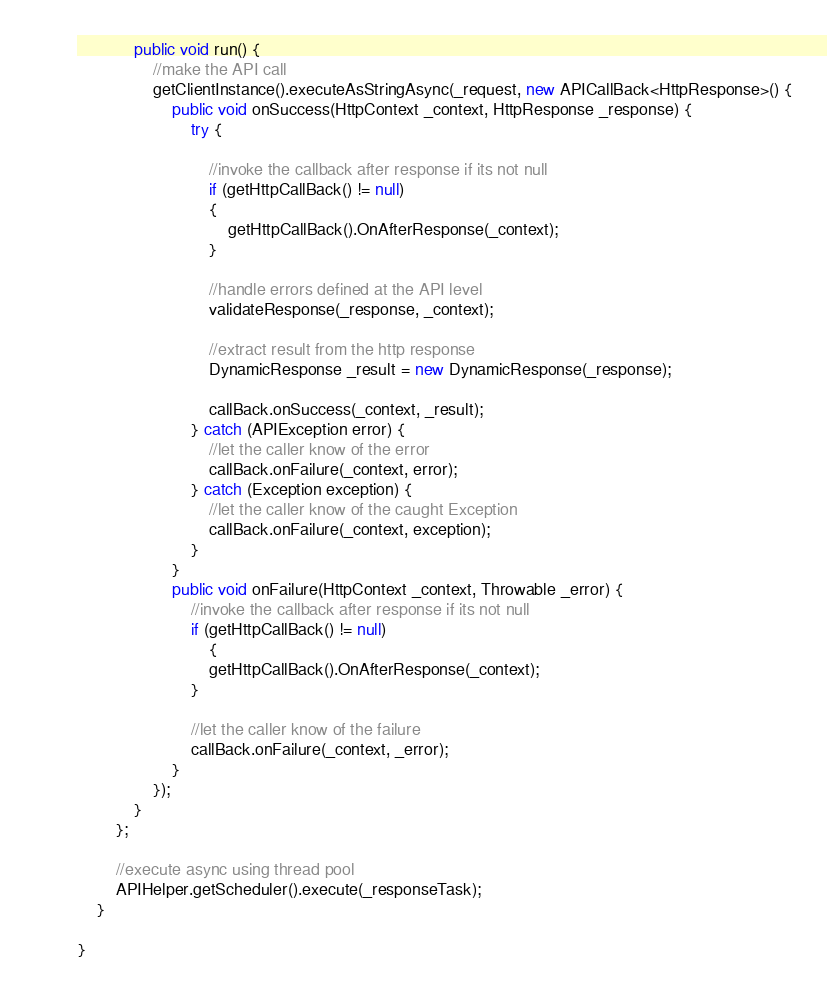<code> <loc_0><loc_0><loc_500><loc_500><_Java_>            public void run() {
                //make the API call
                getClientInstance().executeAsStringAsync(_request, new APICallBack<HttpResponse>() {
                    public void onSuccess(HttpContext _context, HttpResponse _response) {
                        try {

                            //invoke the callback after response if its not null
                            if (getHttpCallBack() != null)	
                            {
                                getHttpCallBack().OnAfterResponse(_context);
                            }

                            //handle errors defined at the API level
                            validateResponse(_response, _context);

                            //extract result from the http response
                            DynamicResponse _result = new DynamicResponse(_response);

                            callBack.onSuccess(_context, _result);
                        } catch (APIException error) {
                            //let the caller know of the error
                            callBack.onFailure(_context, error);
                        } catch (Exception exception) {
                            //let the caller know of the caught Exception
                            callBack.onFailure(_context, exception);
                        }
                    }
                    public void onFailure(HttpContext _context, Throwable _error) {
                        //invoke the callback after response if its not null
                        if (getHttpCallBack() != null)	
                            {
                            getHttpCallBack().OnAfterResponse(_context);
                        }

                        //let the caller know of the failure
                        callBack.onFailure(_context, _error);
                    }
                });
            }
        };

        //execute async using thread pool
        APIHelper.getScheduler().execute(_responseTask);
    }

}</code> 